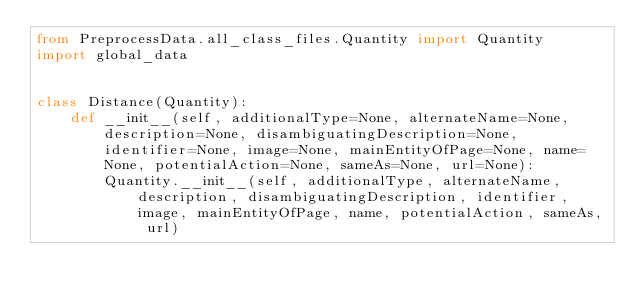<code> <loc_0><loc_0><loc_500><loc_500><_Python_>from PreprocessData.all_class_files.Quantity import Quantity
import global_data


class Distance(Quantity):
    def __init__(self, additionalType=None, alternateName=None, description=None, disambiguatingDescription=None, identifier=None, image=None, mainEntityOfPage=None, name=None, potentialAction=None, sameAs=None, url=None):
        Quantity.__init__(self, additionalType, alternateName, description, disambiguatingDescription, identifier, image, mainEntityOfPage, name, potentialAction, sameAs, url)
</code> 